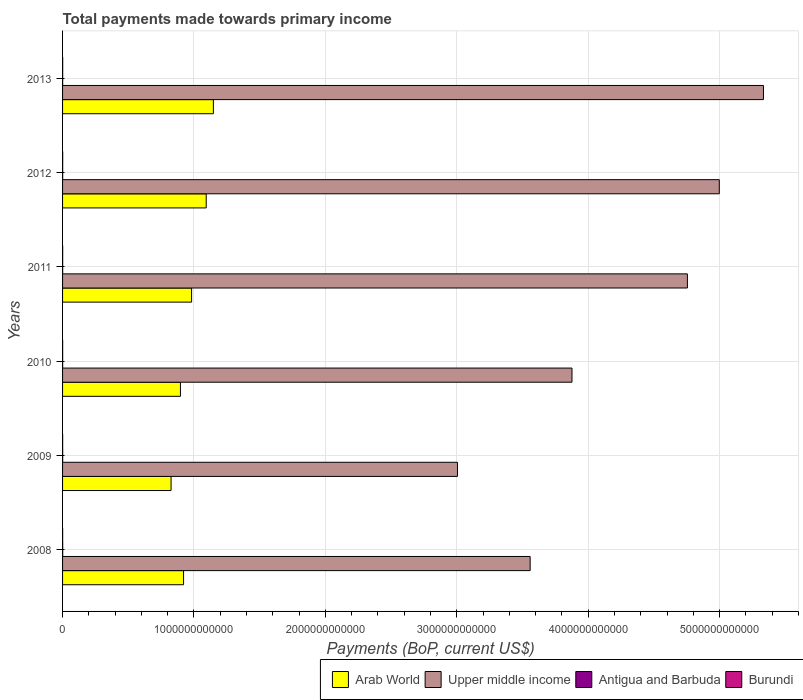Are the number of bars per tick equal to the number of legend labels?
Your answer should be very brief. Yes. Are the number of bars on each tick of the Y-axis equal?
Offer a very short reply. Yes. How many bars are there on the 2nd tick from the top?
Offer a very short reply. 4. What is the label of the 4th group of bars from the top?
Keep it short and to the point. 2010. In how many cases, is the number of bars for a given year not equal to the number of legend labels?
Provide a succinct answer. 0. What is the total payments made towards primary income in Burundi in 2012?
Provide a short and direct response. 9.41e+08. Across all years, what is the maximum total payments made towards primary income in Upper middle income?
Your answer should be compact. 5.33e+12. Across all years, what is the minimum total payments made towards primary income in Burundi?
Provide a succinct answer. 5.38e+08. What is the total total payments made towards primary income in Burundi in the graph?
Your answer should be very brief. 4.42e+09. What is the difference between the total payments made towards primary income in Upper middle income in 2010 and that in 2012?
Keep it short and to the point. -1.12e+12. What is the difference between the total payments made towards primary income in Burundi in 2010 and the total payments made towards primary income in Upper middle income in 2011?
Offer a terse response. -4.75e+12. What is the average total payments made towards primary income in Arab World per year?
Provide a succinct answer. 9.78e+11. In the year 2013, what is the difference between the total payments made towards primary income in Burundi and total payments made towards primary income in Arab World?
Make the answer very short. -1.15e+12. In how many years, is the total payments made towards primary income in Upper middle income greater than 1600000000000 US$?
Keep it short and to the point. 6. What is the ratio of the total payments made towards primary income in Antigua and Barbuda in 2009 to that in 2013?
Your response must be concise. 0.99. What is the difference between the highest and the second highest total payments made towards primary income in Antigua and Barbuda?
Keep it short and to the point. 2.55e+08. What is the difference between the highest and the lowest total payments made towards primary income in Antigua and Barbuda?
Ensure brevity in your answer.  3.38e+08. Is the sum of the total payments made towards primary income in Burundi in 2010 and 2013 greater than the maximum total payments made towards primary income in Arab World across all years?
Make the answer very short. No. Is it the case that in every year, the sum of the total payments made towards primary income in Upper middle income and total payments made towards primary income in Arab World is greater than the sum of total payments made towards primary income in Burundi and total payments made towards primary income in Antigua and Barbuda?
Keep it short and to the point. Yes. What does the 2nd bar from the top in 2008 represents?
Keep it short and to the point. Antigua and Barbuda. What does the 3rd bar from the bottom in 2010 represents?
Offer a very short reply. Antigua and Barbuda. Is it the case that in every year, the sum of the total payments made towards primary income in Upper middle income and total payments made towards primary income in Antigua and Barbuda is greater than the total payments made towards primary income in Arab World?
Provide a short and direct response. Yes. Are all the bars in the graph horizontal?
Give a very brief answer. Yes. How many years are there in the graph?
Offer a very short reply. 6. What is the difference between two consecutive major ticks on the X-axis?
Your answer should be very brief. 1.00e+12. Are the values on the major ticks of X-axis written in scientific E-notation?
Offer a terse response. No. Does the graph contain any zero values?
Keep it short and to the point. No. Does the graph contain grids?
Keep it short and to the point. Yes. Where does the legend appear in the graph?
Keep it short and to the point. Bottom right. What is the title of the graph?
Offer a very short reply. Total payments made towards primary income. Does "Ghana" appear as one of the legend labels in the graph?
Offer a terse response. No. What is the label or title of the X-axis?
Offer a terse response. Payments (BoP, current US$). What is the Payments (BoP, current US$) of Arab World in 2008?
Your answer should be very brief. 9.21e+11. What is the Payments (BoP, current US$) in Upper middle income in 2008?
Provide a short and direct response. 3.56e+12. What is the Payments (BoP, current US$) in Antigua and Barbuda in 2008?
Your response must be concise. 1.03e+09. What is the Payments (BoP, current US$) in Burundi in 2008?
Provide a short and direct response. 6.09e+08. What is the Payments (BoP, current US$) in Arab World in 2009?
Offer a very short reply. 8.26e+11. What is the Payments (BoP, current US$) of Upper middle income in 2009?
Provide a short and direct response. 3.01e+12. What is the Payments (BoP, current US$) of Antigua and Barbuda in 2009?
Your answer should be very brief. 7.70e+08. What is the Payments (BoP, current US$) of Burundi in 2009?
Your response must be concise. 5.38e+08. What is the Payments (BoP, current US$) of Arab World in 2010?
Offer a very short reply. 8.97e+11. What is the Payments (BoP, current US$) in Upper middle income in 2010?
Keep it short and to the point. 3.88e+12. What is the Payments (BoP, current US$) of Antigua and Barbuda in 2010?
Ensure brevity in your answer.  7.22e+08. What is the Payments (BoP, current US$) in Burundi in 2010?
Keep it short and to the point. 6.19e+08. What is the Payments (BoP, current US$) of Arab World in 2011?
Offer a terse response. 9.82e+11. What is the Payments (BoP, current US$) in Upper middle income in 2011?
Give a very brief answer. 4.76e+12. What is the Payments (BoP, current US$) in Antigua and Barbuda in 2011?
Make the answer very short. 6.91e+08. What is the Payments (BoP, current US$) in Burundi in 2011?
Your answer should be compact. 7.90e+08. What is the Payments (BoP, current US$) of Arab World in 2012?
Offer a very short reply. 1.09e+12. What is the Payments (BoP, current US$) of Upper middle income in 2012?
Offer a terse response. 5.00e+12. What is the Payments (BoP, current US$) in Antigua and Barbuda in 2012?
Your answer should be very brief. 7.49e+08. What is the Payments (BoP, current US$) in Burundi in 2012?
Provide a succinct answer. 9.41e+08. What is the Payments (BoP, current US$) of Arab World in 2013?
Keep it short and to the point. 1.15e+12. What is the Payments (BoP, current US$) of Upper middle income in 2013?
Make the answer very short. 5.33e+12. What is the Payments (BoP, current US$) in Antigua and Barbuda in 2013?
Your answer should be very brief. 7.75e+08. What is the Payments (BoP, current US$) in Burundi in 2013?
Offer a very short reply. 9.22e+08. Across all years, what is the maximum Payments (BoP, current US$) in Arab World?
Your answer should be compact. 1.15e+12. Across all years, what is the maximum Payments (BoP, current US$) in Upper middle income?
Your answer should be very brief. 5.33e+12. Across all years, what is the maximum Payments (BoP, current US$) of Antigua and Barbuda?
Ensure brevity in your answer.  1.03e+09. Across all years, what is the maximum Payments (BoP, current US$) in Burundi?
Provide a succinct answer. 9.41e+08. Across all years, what is the minimum Payments (BoP, current US$) of Arab World?
Offer a terse response. 8.26e+11. Across all years, what is the minimum Payments (BoP, current US$) of Upper middle income?
Your answer should be very brief. 3.01e+12. Across all years, what is the minimum Payments (BoP, current US$) of Antigua and Barbuda?
Your answer should be very brief. 6.91e+08. Across all years, what is the minimum Payments (BoP, current US$) in Burundi?
Ensure brevity in your answer.  5.38e+08. What is the total Payments (BoP, current US$) in Arab World in the graph?
Your answer should be very brief. 5.87e+12. What is the total Payments (BoP, current US$) of Upper middle income in the graph?
Your answer should be compact. 2.55e+13. What is the total Payments (BoP, current US$) of Antigua and Barbuda in the graph?
Give a very brief answer. 4.74e+09. What is the total Payments (BoP, current US$) of Burundi in the graph?
Your answer should be very brief. 4.42e+09. What is the difference between the Payments (BoP, current US$) of Arab World in 2008 and that in 2009?
Offer a terse response. 9.51e+1. What is the difference between the Payments (BoP, current US$) in Upper middle income in 2008 and that in 2009?
Your response must be concise. 5.53e+11. What is the difference between the Payments (BoP, current US$) in Antigua and Barbuda in 2008 and that in 2009?
Your response must be concise. 2.59e+08. What is the difference between the Payments (BoP, current US$) in Burundi in 2008 and that in 2009?
Offer a terse response. 7.14e+07. What is the difference between the Payments (BoP, current US$) in Arab World in 2008 and that in 2010?
Provide a short and direct response. 2.38e+1. What is the difference between the Payments (BoP, current US$) of Upper middle income in 2008 and that in 2010?
Provide a succinct answer. -3.18e+11. What is the difference between the Payments (BoP, current US$) of Antigua and Barbuda in 2008 and that in 2010?
Your answer should be very brief. 3.08e+08. What is the difference between the Payments (BoP, current US$) in Burundi in 2008 and that in 2010?
Give a very brief answer. -9.31e+06. What is the difference between the Payments (BoP, current US$) in Arab World in 2008 and that in 2011?
Make the answer very short. -6.11e+1. What is the difference between the Payments (BoP, current US$) of Upper middle income in 2008 and that in 2011?
Your answer should be very brief. -1.20e+12. What is the difference between the Payments (BoP, current US$) of Antigua and Barbuda in 2008 and that in 2011?
Keep it short and to the point. 3.38e+08. What is the difference between the Payments (BoP, current US$) of Burundi in 2008 and that in 2011?
Your answer should be very brief. -1.81e+08. What is the difference between the Payments (BoP, current US$) of Arab World in 2008 and that in 2012?
Provide a short and direct response. -1.72e+11. What is the difference between the Payments (BoP, current US$) of Upper middle income in 2008 and that in 2012?
Your answer should be compact. -1.44e+12. What is the difference between the Payments (BoP, current US$) in Antigua and Barbuda in 2008 and that in 2012?
Provide a short and direct response. 2.80e+08. What is the difference between the Payments (BoP, current US$) in Burundi in 2008 and that in 2012?
Your response must be concise. -3.31e+08. What is the difference between the Payments (BoP, current US$) of Arab World in 2008 and that in 2013?
Give a very brief answer. -2.27e+11. What is the difference between the Payments (BoP, current US$) in Upper middle income in 2008 and that in 2013?
Keep it short and to the point. -1.78e+12. What is the difference between the Payments (BoP, current US$) of Antigua and Barbuda in 2008 and that in 2013?
Offer a very short reply. 2.55e+08. What is the difference between the Payments (BoP, current US$) in Burundi in 2008 and that in 2013?
Offer a terse response. -3.12e+08. What is the difference between the Payments (BoP, current US$) in Arab World in 2009 and that in 2010?
Your answer should be compact. -7.13e+1. What is the difference between the Payments (BoP, current US$) in Upper middle income in 2009 and that in 2010?
Offer a very short reply. -8.71e+11. What is the difference between the Payments (BoP, current US$) of Antigua and Barbuda in 2009 and that in 2010?
Provide a succinct answer. 4.88e+07. What is the difference between the Payments (BoP, current US$) in Burundi in 2009 and that in 2010?
Keep it short and to the point. -8.07e+07. What is the difference between the Payments (BoP, current US$) in Arab World in 2009 and that in 2011?
Your answer should be very brief. -1.56e+11. What is the difference between the Payments (BoP, current US$) of Upper middle income in 2009 and that in 2011?
Give a very brief answer. -1.75e+12. What is the difference between the Payments (BoP, current US$) in Antigua and Barbuda in 2009 and that in 2011?
Make the answer very short. 7.91e+07. What is the difference between the Payments (BoP, current US$) in Burundi in 2009 and that in 2011?
Ensure brevity in your answer.  -2.52e+08. What is the difference between the Payments (BoP, current US$) of Arab World in 2009 and that in 2012?
Your answer should be very brief. -2.68e+11. What is the difference between the Payments (BoP, current US$) in Upper middle income in 2009 and that in 2012?
Give a very brief answer. -1.99e+12. What is the difference between the Payments (BoP, current US$) in Antigua and Barbuda in 2009 and that in 2012?
Ensure brevity in your answer.  2.12e+07. What is the difference between the Payments (BoP, current US$) in Burundi in 2009 and that in 2012?
Offer a terse response. -4.03e+08. What is the difference between the Payments (BoP, current US$) of Arab World in 2009 and that in 2013?
Ensure brevity in your answer.  -3.22e+11. What is the difference between the Payments (BoP, current US$) in Upper middle income in 2009 and that in 2013?
Make the answer very short. -2.33e+12. What is the difference between the Payments (BoP, current US$) in Antigua and Barbuda in 2009 and that in 2013?
Provide a short and direct response. -4.27e+06. What is the difference between the Payments (BoP, current US$) in Burundi in 2009 and that in 2013?
Make the answer very short. -3.84e+08. What is the difference between the Payments (BoP, current US$) in Arab World in 2010 and that in 2011?
Offer a terse response. -8.49e+1. What is the difference between the Payments (BoP, current US$) of Upper middle income in 2010 and that in 2011?
Keep it short and to the point. -8.78e+11. What is the difference between the Payments (BoP, current US$) of Antigua and Barbuda in 2010 and that in 2011?
Ensure brevity in your answer.  3.02e+07. What is the difference between the Payments (BoP, current US$) in Burundi in 2010 and that in 2011?
Your answer should be very brief. -1.72e+08. What is the difference between the Payments (BoP, current US$) in Arab World in 2010 and that in 2012?
Provide a succinct answer. -1.96e+11. What is the difference between the Payments (BoP, current US$) in Upper middle income in 2010 and that in 2012?
Your answer should be compact. -1.12e+12. What is the difference between the Payments (BoP, current US$) in Antigua and Barbuda in 2010 and that in 2012?
Your response must be concise. -2.77e+07. What is the difference between the Payments (BoP, current US$) of Burundi in 2010 and that in 2012?
Keep it short and to the point. -3.22e+08. What is the difference between the Payments (BoP, current US$) of Arab World in 2010 and that in 2013?
Your answer should be very brief. -2.51e+11. What is the difference between the Payments (BoP, current US$) of Upper middle income in 2010 and that in 2013?
Offer a terse response. -1.46e+12. What is the difference between the Payments (BoP, current US$) in Antigua and Barbuda in 2010 and that in 2013?
Ensure brevity in your answer.  -5.31e+07. What is the difference between the Payments (BoP, current US$) in Burundi in 2010 and that in 2013?
Give a very brief answer. -3.03e+08. What is the difference between the Payments (BoP, current US$) in Arab World in 2011 and that in 2012?
Ensure brevity in your answer.  -1.11e+11. What is the difference between the Payments (BoP, current US$) in Upper middle income in 2011 and that in 2012?
Offer a very short reply. -2.43e+11. What is the difference between the Payments (BoP, current US$) of Antigua and Barbuda in 2011 and that in 2012?
Provide a succinct answer. -5.79e+07. What is the difference between the Payments (BoP, current US$) of Burundi in 2011 and that in 2012?
Ensure brevity in your answer.  -1.50e+08. What is the difference between the Payments (BoP, current US$) in Arab World in 2011 and that in 2013?
Give a very brief answer. -1.66e+11. What is the difference between the Payments (BoP, current US$) in Upper middle income in 2011 and that in 2013?
Offer a very short reply. -5.79e+11. What is the difference between the Payments (BoP, current US$) of Antigua and Barbuda in 2011 and that in 2013?
Your answer should be compact. -8.33e+07. What is the difference between the Payments (BoP, current US$) in Burundi in 2011 and that in 2013?
Give a very brief answer. -1.32e+08. What is the difference between the Payments (BoP, current US$) in Arab World in 2012 and that in 2013?
Your answer should be very brief. -5.44e+1. What is the difference between the Payments (BoP, current US$) in Upper middle income in 2012 and that in 2013?
Provide a short and direct response. -3.36e+11. What is the difference between the Payments (BoP, current US$) in Antigua and Barbuda in 2012 and that in 2013?
Keep it short and to the point. -2.54e+07. What is the difference between the Payments (BoP, current US$) of Burundi in 2012 and that in 2013?
Ensure brevity in your answer.  1.87e+07. What is the difference between the Payments (BoP, current US$) in Arab World in 2008 and the Payments (BoP, current US$) in Upper middle income in 2009?
Your response must be concise. -2.08e+12. What is the difference between the Payments (BoP, current US$) in Arab World in 2008 and the Payments (BoP, current US$) in Antigua and Barbuda in 2009?
Ensure brevity in your answer.  9.20e+11. What is the difference between the Payments (BoP, current US$) of Arab World in 2008 and the Payments (BoP, current US$) of Burundi in 2009?
Give a very brief answer. 9.20e+11. What is the difference between the Payments (BoP, current US$) in Upper middle income in 2008 and the Payments (BoP, current US$) in Antigua and Barbuda in 2009?
Your answer should be very brief. 3.56e+12. What is the difference between the Payments (BoP, current US$) of Upper middle income in 2008 and the Payments (BoP, current US$) of Burundi in 2009?
Keep it short and to the point. 3.56e+12. What is the difference between the Payments (BoP, current US$) in Antigua and Barbuda in 2008 and the Payments (BoP, current US$) in Burundi in 2009?
Your answer should be compact. 4.91e+08. What is the difference between the Payments (BoP, current US$) of Arab World in 2008 and the Payments (BoP, current US$) of Upper middle income in 2010?
Provide a succinct answer. -2.96e+12. What is the difference between the Payments (BoP, current US$) in Arab World in 2008 and the Payments (BoP, current US$) in Antigua and Barbuda in 2010?
Make the answer very short. 9.20e+11. What is the difference between the Payments (BoP, current US$) in Arab World in 2008 and the Payments (BoP, current US$) in Burundi in 2010?
Your answer should be compact. 9.20e+11. What is the difference between the Payments (BoP, current US$) of Upper middle income in 2008 and the Payments (BoP, current US$) of Antigua and Barbuda in 2010?
Provide a succinct answer. 3.56e+12. What is the difference between the Payments (BoP, current US$) of Upper middle income in 2008 and the Payments (BoP, current US$) of Burundi in 2010?
Ensure brevity in your answer.  3.56e+12. What is the difference between the Payments (BoP, current US$) of Antigua and Barbuda in 2008 and the Payments (BoP, current US$) of Burundi in 2010?
Give a very brief answer. 4.11e+08. What is the difference between the Payments (BoP, current US$) of Arab World in 2008 and the Payments (BoP, current US$) of Upper middle income in 2011?
Provide a short and direct response. -3.83e+12. What is the difference between the Payments (BoP, current US$) of Arab World in 2008 and the Payments (BoP, current US$) of Antigua and Barbuda in 2011?
Provide a short and direct response. 9.20e+11. What is the difference between the Payments (BoP, current US$) in Arab World in 2008 and the Payments (BoP, current US$) in Burundi in 2011?
Keep it short and to the point. 9.20e+11. What is the difference between the Payments (BoP, current US$) of Upper middle income in 2008 and the Payments (BoP, current US$) of Antigua and Barbuda in 2011?
Offer a terse response. 3.56e+12. What is the difference between the Payments (BoP, current US$) of Upper middle income in 2008 and the Payments (BoP, current US$) of Burundi in 2011?
Your answer should be compact. 3.56e+12. What is the difference between the Payments (BoP, current US$) of Antigua and Barbuda in 2008 and the Payments (BoP, current US$) of Burundi in 2011?
Provide a succinct answer. 2.39e+08. What is the difference between the Payments (BoP, current US$) in Arab World in 2008 and the Payments (BoP, current US$) in Upper middle income in 2012?
Offer a very short reply. -4.08e+12. What is the difference between the Payments (BoP, current US$) in Arab World in 2008 and the Payments (BoP, current US$) in Antigua and Barbuda in 2012?
Keep it short and to the point. 9.20e+11. What is the difference between the Payments (BoP, current US$) of Arab World in 2008 and the Payments (BoP, current US$) of Burundi in 2012?
Your answer should be compact. 9.20e+11. What is the difference between the Payments (BoP, current US$) of Upper middle income in 2008 and the Payments (BoP, current US$) of Antigua and Barbuda in 2012?
Give a very brief answer. 3.56e+12. What is the difference between the Payments (BoP, current US$) of Upper middle income in 2008 and the Payments (BoP, current US$) of Burundi in 2012?
Offer a very short reply. 3.56e+12. What is the difference between the Payments (BoP, current US$) in Antigua and Barbuda in 2008 and the Payments (BoP, current US$) in Burundi in 2012?
Make the answer very short. 8.88e+07. What is the difference between the Payments (BoP, current US$) in Arab World in 2008 and the Payments (BoP, current US$) in Upper middle income in 2013?
Keep it short and to the point. -4.41e+12. What is the difference between the Payments (BoP, current US$) of Arab World in 2008 and the Payments (BoP, current US$) of Antigua and Barbuda in 2013?
Your answer should be compact. 9.20e+11. What is the difference between the Payments (BoP, current US$) in Arab World in 2008 and the Payments (BoP, current US$) in Burundi in 2013?
Your answer should be compact. 9.20e+11. What is the difference between the Payments (BoP, current US$) in Upper middle income in 2008 and the Payments (BoP, current US$) in Antigua and Barbuda in 2013?
Offer a terse response. 3.56e+12. What is the difference between the Payments (BoP, current US$) in Upper middle income in 2008 and the Payments (BoP, current US$) in Burundi in 2013?
Provide a succinct answer. 3.56e+12. What is the difference between the Payments (BoP, current US$) in Antigua and Barbuda in 2008 and the Payments (BoP, current US$) in Burundi in 2013?
Offer a very short reply. 1.07e+08. What is the difference between the Payments (BoP, current US$) in Arab World in 2009 and the Payments (BoP, current US$) in Upper middle income in 2010?
Give a very brief answer. -3.05e+12. What is the difference between the Payments (BoP, current US$) of Arab World in 2009 and the Payments (BoP, current US$) of Antigua and Barbuda in 2010?
Keep it short and to the point. 8.25e+11. What is the difference between the Payments (BoP, current US$) in Arab World in 2009 and the Payments (BoP, current US$) in Burundi in 2010?
Keep it short and to the point. 8.25e+11. What is the difference between the Payments (BoP, current US$) in Upper middle income in 2009 and the Payments (BoP, current US$) in Antigua and Barbuda in 2010?
Your answer should be compact. 3.00e+12. What is the difference between the Payments (BoP, current US$) in Upper middle income in 2009 and the Payments (BoP, current US$) in Burundi in 2010?
Offer a very short reply. 3.00e+12. What is the difference between the Payments (BoP, current US$) of Antigua and Barbuda in 2009 and the Payments (BoP, current US$) of Burundi in 2010?
Offer a very short reply. 1.52e+08. What is the difference between the Payments (BoP, current US$) of Arab World in 2009 and the Payments (BoP, current US$) of Upper middle income in 2011?
Your answer should be compact. -3.93e+12. What is the difference between the Payments (BoP, current US$) in Arab World in 2009 and the Payments (BoP, current US$) in Antigua and Barbuda in 2011?
Offer a terse response. 8.25e+11. What is the difference between the Payments (BoP, current US$) of Arab World in 2009 and the Payments (BoP, current US$) of Burundi in 2011?
Provide a short and direct response. 8.25e+11. What is the difference between the Payments (BoP, current US$) of Upper middle income in 2009 and the Payments (BoP, current US$) of Antigua and Barbuda in 2011?
Your answer should be compact. 3.00e+12. What is the difference between the Payments (BoP, current US$) in Upper middle income in 2009 and the Payments (BoP, current US$) in Burundi in 2011?
Offer a very short reply. 3.00e+12. What is the difference between the Payments (BoP, current US$) of Antigua and Barbuda in 2009 and the Payments (BoP, current US$) of Burundi in 2011?
Your answer should be compact. -1.99e+07. What is the difference between the Payments (BoP, current US$) in Arab World in 2009 and the Payments (BoP, current US$) in Upper middle income in 2012?
Your response must be concise. -4.17e+12. What is the difference between the Payments (BoP, current US$) in Arab World in 2009 and the Payments (BoP, current US$) in Antigua and Barbuda in 2012?
Make the answer very short. 8.25e+11. What is the difference between the Payments (BoP, current US$) in Arab World in 2009 and the Payments (BoP, current US$) in Burundi in 2012?
Keep it short and to the point. 8.25e+11. What is the difference between the Payments (BoP, current US$) in Upper middle income in 2009 and the Payments (BoP, current US$) in Antigua and Barbuda in 2012?
Provide a succinct answer. 3.00e+12. What is the difference between the Payments (BoP, current US$) of Upper middle income in 2009 and the Payments (BoP, current US$) of Burundi in 2012?
Your answer should be very brief. 3.00e+12. What is the difference between the Payments (BoP, current US$) of Antigua and Barbuda in 2009 and the Payments (BoP, current US$) of Burundi in 2012?
Ensure brevity in your answer.  -1.70e+08. What is the difference between the Payments (BoP, current US$) of Arab World in 2009 and the Payments (BoP, current US$) of Upper middle income in 2013?
Provide a succinct answer. -4.51e+12. What is the difference between the Payments (BoP, current US$) of Arab World in 2009 and the Payments (BoP, current US$) of Antigua and Barbuda in 2013?
Your answer should be very brief. 8.25e+11. What is the difference between the Payments (BoP, current US$) of Arab World in 2009 and the Payments (BoP, current US$) of Burundi in 2013?
Offer a very short reply. 8.25e+11. What is the difference between the Payments (BoP, current US$) of Upper middle income in 2009 and the Payments (BoP, current US$) of Antigua and Barbuda in 2013?
Your response must be concise. 3.00e+12. What is the difference between the Payments (BoP, current US$) in Upper middle income in 2009 and the Payments (BoP, current US$) in Burundi in 2013?
Make the answer very short. 3.00e+12. What is the difference between the Payments (BoP, current US$) in Antigua and Barbuda in 2009 and the Payments (BoP, current US$) in Burundi in 2013?
Make the answer very short. -1.52e+08. What is the difference between the Payments (BoP, current US$) of Arab World in 2010 and the Payments (BoP, current US$) of Upper middle income in 2011?
Offer a terse response. -3.86e+12. What is the difference between the Payments (BoP, current US$) of Arab World in 2010 and the Payments (BoP, current US$) of Antigua and Barbuda in 2011?
Your answer should be very brief. 8.96e+11. What is the difference between the Payments (BoP, current US$) of Arab World in 2010 and the Payments (BoP, current US$) of Burundi in 2011?
Your response must be concise. 8.96e+11. What is the difference between the Payments (BoP, current US$) of Upper middle income in 2010 and the Payments (BoP, current US$) of Antigua and Barbuda in 2011?
Ensure brevity in your answer.  3.88e+12. What is the difference between the Payments (BoP, current US$) of Upper middle income in 2010 and the Payments (BoP, current US$) of Burundi in 2011?
Your answer should be very brief. 3.88e+12. What is the difference between the Payments (BoP, current US$) of Antigua and Barbuda in 2010 and the Payments (BoP, current US$) of Burundi in 2011?
Offer a terse response. -6.87e+07. What is the difference between the Payments (BoP, current US$) of Arab World in 2010 and the Payments (BoP, current US$) of Upper middle income in 2012?
Offer a terse response. -4.10e+12. What is the difference between the Payments (BoP, current US$) in Arab World in 2010 and the Payments (BoP, current US$) in Antigua and Barbuda in 2012?
Ensure brevity in your answer.  8.96e+11. What is the difference between the Payments (BoP, current US$) of Arab World in 2010 and the Payments (BoP, current US$) of Burundi in 2012?
Provide a succinct answer. 8.96e+11. What is the difference between the Payments (BoP, current US$) of Upper middle income in 2010 and the Payments (BoP, current US$) of Antigua and Barbuda in 2012?
Provide a succinct answer. 3.88e+12. What is the difference between the Payments (BoP, current US$) of Upper middle income in 2010 and the Payments (BoP, current US$) of Burundi in 2012?
Offer a very short reply. 3.88e+12. What is the difference between the Payments (BoP, current US$) in Antigua and Barbuda in 2010 and the Payments (BoP, current US$) in Burundi in 2012?
Offer a terse response. -2.19e+08. What is the difference between the Payments (BoP, current US$) of Arab World in 2010 and the Payments (BoP, current US$) of Upper middle income in 2013?
Provide a succinct answer. -4.44e+12. What is the difference between the Payments (BoP, current US$) of Arab World in 2010 and the Payments (BoP, current US$) of Antigua and Barbuda in 2013?
Provide a short and direct response. 8.96e+11. What is the difference between the Payments (BoP, current US$) in Arab World in 2010 and the Payments (BoP, current US$) in Burundi in 2013?
Provide a succinct answer. 8.96e+11. What is the difference between the Payments (BoP, current US$) in Upper middle income in 2010 and the Payments (BoP, current US$) in Antigua and Barbuda in 2013?
Your response must be concise. 3.88e+12. What is the difference between the Payments (BoP, current US$) of Upper middle income in 2010 and the Payments (BoP, current US$) of Burundi in 2013?
Keep it short and to the point. 3.88e+12. What is the difference between the Payments (BoP, current US$) of Antigua and Barbuda in 2010 and the Payments (BoP, current US$) of Burundi in 2013?
Offer a very short reply. -2.00e+08. What is the difference between the Payments (BoP, current US$) of Arab World in 2011 and the Payments (BoP, current US$) of Upper middle income in 2012?
Your answer should be compact. -4.02e+12. What is the difference between the Payments (BoP, current US$) in Arab World in 2011 and the Payments (BoP, current US$) in Antigua and Barbuda in 2012?
Offer a terse response. 9.81e+11. What is the difference between the Payments (BoP, current US$) in Arab World in 2011 and the Payments (BoP, current US$) in Burundi in 2012?
Your answer should be compact. 9.81e+11. What is the difference between the Payments (BoP, current US$) in Upper middle income in 2011 and the Payments (BoP, current US$) in Antigua and Barbuda in 2012?
Provide a short and direct response. 4.75e+12. What is the difference between the Payments (BoP, current US$) in Upper middle income in 2011 and the Payments (BoP, current US$) in Burundi in 2012?
Ensure brevity in your answer.  4.75e+12. What is the difference between the Payments (BoP, current US$) in Antigua and Barbuda in 2011 and the Payments (BoP, current US$) in Burundi in 2012?
Provide a short and direct response. -2.49e+08. What is the difference between the Payments (BoP, current US$) in Arab World in 2011 and the Payments (BoP, current US$) in Upper middle income in 2013?
Give a very brief answer. -4.35e+12. What is the difference between the Payments (BoP, current US$) of Arab World in 2011 and the Payments (BoP, current US$) of Antigua and Barbuda in 2013?
Your answer should be very brief. 9.81e+11. What is the difference between the Payments (BoP, current US$) of Arab World in 2011 and the Payments (BoP, current US$) of Burundi in 2013?
Your response must be concise. 9.81e+11. What is the difference between the Payments (BoP, current US$) of Upper middle income in 2011 and the Payments (BoP, current US$) of Antigua and Barbuda in 2013?
Give a very brief answer. 4.75e+12. What is the difference between the Payments (BoP, current US$) of Upper middle income in 2011 and the Payments (BoP, current US$) of Burundi in 2013?
Keep it short and to the point. 4.75e+12. What is the difference between the Payments (BoP, current US$) of Antigua and Barbuda in 2011 and the Payments (BoP, current US$) of Burundi in 2013?
Keep it short and to the point. -2.31e+08. What is the difference between the Payments (BoP, current US$) of Arab World in 2012 and the Payments (BoP, current US$) of Upper middle income in 2013?
Your response must be concise. -4.24e+12. What is the difference between the Payments (BoP, current US$) of Arab World in 2012 and the Payments (BoP, current US$) of Antigua and Barbuda in 2013?
Your answer should be very brief. 1.09e+12. What is the difference between the Payments (BoP, current US$) in Arab World in 2012 and the Payments (BoP, current US$) in Burundi in 2013?
Your response must be concise. 1.09e+12. What is the difference between the Payments (BoP, current US$) in Upper middle income in 2012 and the Payments (BoP, current US$) in Antigua and Barbuda in 2013?
Your answer should be compact. 5.00e+12. What is the difference between the Payments (BoP, current US$) of Upper middle income in 2012 and the Payments (BoP, current US$) of Burundi in 2013?
Offer a very short reply. 5.00e+12. What is the difference between the Payments (BoP, current US$) in Antigua and Barbuda in 2012 and the Payments (BoP, current US$) in Burundi in 2013?
Your answer should be very brief. -1.73e+08. What is the average Payments (BoP, current US$) of Arab World per year?
Provide a succinct answer. 9.78e+11. What is the average Payments (BoP, current US$) in Upper middle income per year?
Your answer should be very brief. 4.25e+12. What is the average Payments (BoP, current US$) of Antigua and Barbuda per year?
Your response must be concise. 7.89e+08. What is the average Payments (BoP, current US$) in Burundi per year?
Offer a terse response. 7.36e+08. In the year 2008, what is the difference between the Payments (BoP, current US$) in Arab World and Payments (BoP, current US$) in Upper middle income?
Offer a terse response. -2.64e+12. In the year 2008, what is the difference between the Payments (BoP, current US$) of Arab World and Payments (BoP, current US$) of Antigua and Barbuda?
Your response must be concise. 9.20e+11. In the year 2008, what is the difference between the Payments (BoP, current US$) of Arab World and Payments (BoP, current US$) of Burundi?
Keep it short and to the point. 9.20e+11. In the year 2008, what is the difference between the Payments (BoP, current US$) of Upper middle income and Payments (BoP, current US$) of Antigua and Barbuda?
Keep it short and to the point. 3.56e+12. In the year 2008, what is the difference between the Payments (BoP, current US$) in Upper middle income and Payments (BoP, current US$) in Burundi?
Provide a short and direct response. 3.56e+12. In the year 2008, what is the difference between the Payments (BoP, current US$) of Antigua and Barbuda and Payments (BoP, current US$) of Burundi?
Offer a very short reply. 4.20e+08. In the year 2009, what is the difference between the Payments (BoP, current US$) of Arab World and Payments (BoP, current US$) of Upper middle income?
Your answer should be very brief. -2.18e+12. In the year 2009, what is the difference between the Payments (BoP, current US$) in Arab World and Payments (BoP, current US$) in Antigua and Barbuda?
Provide a succinct answer. 8.25e+11. In the year 2009, what is the difference between the Payments (BoP, current US$) in Arab World and Payments (BoP, current US$) in Burundi?
Your answer should be compact. 8.25e+11. In the year 2009, what is the difference between the Payments (BoP, current US$) of Upper middle income and Payments (BoP, current US$) of Antigua and Barbuda?
Provide a succinct answer. 3.00e+12. In the year 2009, what is the difference between the Payments (BoP, current US$) of Upper middle income and Payments (BoP, current US$) of Burundi?
Provide a short and direct response. 3.00e+12. In the year 2009, what is the difference between the Payments (BoP, current US$) of Antigua and Barbuda and Payments (BoP, current US$) of Burundi?
Your answer should be compact. 2.32e+08. In the year 2010, what is the difference between the Payments (BoP, current US$) in Arab World and Payments (BoP, current US$) in Upper middle income?
Keep it short and to the point. -2.98e+12. In the year 2010, what is the difference between the Payments (BoP, current US$) of Arab World and Payments (BoP, current US$) of Antigua and Barbuda?
Keep it short and to the point. 8.96e+11. In the year 2010, what is the difference between the Payments (BoP, current US$) of Arab World and Payments (BoP, current US$) of Burundi?
Offer a very short reply. 8.96e+11. In the year 2010, what is the difference between the Payments (BoP, current US$) in Upper middle income and Payments (BoP, current US$) in Antigua and Barbuda?
Offer a very short reply. 3.88e+12. In the year 2010, what is the difference between the Payments (BoP, current US$) of Upper middle income and Payments (BoP, current US$) of Burundi?
Your response must be concise. 3.88e+12. In the year 2010, what is the difference between the Payments (BoP, current US$) of Antigua and Barbuda and Payments (BoP, current US$) of Burundi?
Your answer should be very brief. 1.03e+08. In the year 2011, what is the difference between the Payments (BoP, current US$) in Arab World and Payments (BoP, current US$) in Upper middle income?
Your answer should be compact. -3.77e+12. In the year 2011, what is the difference between the Payments (BoP, current US$) in Arab World and Payments (BoP, current US$) in Antigua and Barbuda?
Keep it short and to the point. 9.81e+11. In the year 2011, what is the difference between the Payments (BoP, current US$) in Arab World and Payments (BoP, current US$) in Burundi?
Give a very brief answer. 9.81e+11. In the year 2011, what is the difference between the Payments (BoP, current US$) of Upper middle income and Payments (BoP, current US$) of Antigua and Barbuda?
Offer a terse response. 4.75e+12. In the year 2011, what is the difference between the Payments (BoP, current US$) in Upper middle income and Payments (BoP, current US$) in Burundi?
Make the answer very short. 4.75e+12. In the year 2011, what is the difference between the Payments (BoP, current US$) in Antigua and Barbuda and Payments (BoP, current US$) in Burundi?
Offer a very short reply. -9.89e+07. In the year 2012, what is the difference between the Payments (BoP, current US$) of Arab World and Payments (BoP, current US$) of Upper middle income?
Provide a short and direct response. -3.90e+12. In the year 2012, what is the difference between the Payments (BoP, current US$) in Arab World and Payments (BoP, current US$) in Antigua and Barbuda?
Offer a very short reply. 1.09e+12. In the year 2012, what is the difference between the Payments (BoP, current US$) in Arab World and Payments (BoP, current US$) in Burundi?
Provide a short and direct response. 1.09e+12. In the year 2012, what is the difference between the Payments (BoP, current US$) of Upper middle income and Payments (BoP, current US$) of Antigua and Barbuda?
Make the answer very short. 5.00e+12. In the year 2012, what is the difference between the Payments (BoP, current US$) of Upper middle income and Payments (BoP, current US$) of Burundi?
Offer a terse response. 5.00e+12. In the year 2012, what is the difference between the Payments (BoP, current US$) in Antigua and Barbuda and Payments (BoP, current US$) in Burundi?
Your answer should be very brief. -1.91e+08. In the year 2013, what is the difference between the Payments (BoP, current US$) in Arab World and Payments (BoP, current US$) in Upper middle income?
Offer a terse response. -4.19e+12. In the year 2013, what is the difference between the Payments (BoP, current US$) in Arab World and Payments (BoP, current US$) in Antigua and Barbuda?
Make the answer very short. 1.15e+12. In the year 2013, what is the difference between the Payments (BoP, current US$) of Arab World and Payments (BoP, current US$) of Burundi?
Provide a short and direct response. 1.15e+12. In the year 2013, what is the difference between the Payments (BoP, current US$) in Upper middle income and Payments (BoP, current US$) in Antigua and Barbuda?
Provide a succinct answer. 5.33e+12. In the year 2013, what is the difference between the Payments (BoP, current US$) of Upper middle income and Payments (BoP, current US$) of Burundi?
Give a very brief answer. 5.33e+12. In the year 2013, what is the difference between the Payments (BoP, current US$) of Antigua and Barbuda and Payments (BoP, current US$) of Burundi?
Offer a very short reply. -1.47e+08. What is the ratio of the Payments (BoP, current US$) in Arab World in 2008 to that in 2009?
Your response must be concise. 1.12. What is the ratio of the Payments (BoP, current US$) of Upper middle income in 2008 to that in 2009?
Keep it short and to the point. 1.18. What is the ratio of the Payments (BoP, current US$) of Antigua and Barbuda in 2008 to that in 2009?
Keep it short and to the point. 1.34. What is the ratio of the Payments (BoP, current US$) of Burundi in 2008 to that in 2009?
Your response must be concise. 1.13. What is the ratio of the Payments (BoP, current US$) in Arab World in 2008 to that in 2010?
Offer a very short reply. 1.03. What is the ratio of the Payments (BoP, current US$) in Upper middle income in 2008 to that in 2010?
Give a very brief answer. 0.92. What is the ratio of the Payments (BoP, current US$) in Antigua and Barbuda in 2008 to that in 2010?
Provide a short and direct response. 1.43. What is the ratio of the Payments (BoP, current US$) of Burundi in 2008 to that in 2010?
Make the answer very short. 0.98. What is the ratio of the Payments (BoP, current US$) of Arab World in 2008 to that in 2011?
Provide a short and direct response. 0.94. What is the ratio of the Payments (BoP, current US$) in Upper middle income in 2008 to that in 2011?
Your response must be concise. 0.75. What is the ratio of the Payments (BoP, current US$) of Antigua and Barbuda in 2008 to that in 2011?
Your response must be concise. 1.49. What is the ratio of the Payments (BoP, current US$) in Burundi in 2008 to that in 2011?
Keep it short and to the point. 0.77. What is the ratio of the Payments (BoP, current US$) in Arab World in 2008 to that in 2012?
Provide a succinct answer. 0.84. What is the ratio of the Payments (BoP, current US$) in Upper middle income in 2008 to that in 2012?
Your answer should be very brief. 0.71. What is the ratio of the Payments (BoP, current US$) in Antigua and Barbuda in 2008 to that in 2012?
Your answer should be very brief. 1.37. What is the ratio of the Payments (BoP, current US$) in Burundi in 2008 to that in 2012?
Your answer should be compact. 0.65. What is the ratio of the Payments (BoP, current US$) in Arab World in 2008 to that in 2013?
Offer a very short reply. 0.8. What is the ratio of the Payments (BoP, current US$) in Upper middle income in 2008 to that in 2013?
Provide a short and direct response. 0.67. What is the ratio of the Payments (BoP, current US$) of Antigua and Barbuda in 2008 to that in 2013?
Offer a terse response. 1.33. What is the ratio of the Payments (BoP, current US$) of Burundi in 2008 to that in 2013?
Make the answer very short. 0.66. What is the ratio of the Payments (BoP, current US$) in Arab World in 2009 to that in 2010?
Ensure brevity in your answer.  0.92. What is the ratio of the Payments (BoP, current US$) in Upper middle income in 2009 to that in 2010?
Offer a terse response. 0.78. What is the ratio of the Payments (BoP, current US$) of Antigua and Barbuda in 2009 to that in 2010?
Your answer should be compact. 1.07. What is the ratio of the Payments (BoP, current US$) of Burundi in 2009 to that in 2010?
Your answer should be very brief. 0.87. What is the ratio of the Payments (BoP, current US$) of Arab World in 2009 to that in 2011?
Make the answer very short. 0.84. What is the ratio of the Payments (BoP, current US$) of Upper middle income in 2009 to that in 2011?
Your answer should be compact. 0.63. What is the ratio of the Payments (BoP, current US$) in Antigua and Barbuda in 2009 to that in 2011?
Your answer should be very brief. 1.11. What is the ratio of the Payments (BoP, current US$) in Burundi in 2009 to that in 2011?
Your response must be concise. 0.68. What is the ratio of the Payments (BoP, current US$) of Arab World in 2009 to that in 2012?
Make the answer very short. 0.76. What is the ratio of the Payments (BoP, current US$) of Upper middle income in 2009 to that in 2012?
Offer a terse response. 0.6. What is the ratio of the Payments (BoP, current US$) in Antigua and Barbuda in 2009 to that in 2012?
Keep it short and to the point. 1.03. What is the ratio of the Payments (BoP, current US$) of Burundi in 2009 to that in 2012?
Keep it short and to the point. 0.57. What is the ratio of the Payments (BoP, current US$) of Arab World in 2009 to that in 2013?
Offer a terse response. 0.72. What is the ratio of the Payments (BoP, current US$) of Upper middle income in 2009 to that in 2013?
Offer a very short reply. 0.56. What is the ratio of the Payments (BoP, current US$) of Burundi in 2009 to that in 2013?
Provide a succinct answer. 0.58. What is the ratio of the Payments (BoP, current US$) in Arab World in 2010 to that in 2011?
Offer a very short reply. 0.91. What is the ratio of the Payments (BoP, current US$) of Upper middle income in 2010 to that in 2011?
Ensure brevity in your answer.  0.82. What is the ratio of the Payments (BoP, current US$) in Antigua and Barbuda in 2010 to that in 2011?
Give a very brief answer. 1.04. What is the ratio of the Payments (BoP, current US$) in Burundi in 2010 to that in 2011?
Make the answer very short. 0.78. What is the ratio of the Payments (BoP, current US$) of Arab World in 2010 to that in 2012?
Offer a terse response. 0.82. What is the ratio of the Payments (BoP, current US$) of Upper middle income in 2010 to that in 2012?
Ensure brevity in your answer.  0.78. What is the ratio of the Payments (BoP, current US$) of Antigua and Barbuda in 2010 to that in 2012?
Your answer should be very brief. 0.96. What is the ratio of the Payments (BoP, current US$) of Burundi in 2010 to that in 2012?
Your answer should be compact. 0.66. What is the ratio of the Payments (BoP, current US$) of Arab World in 2010 to that in 2013?
Your response must be concise. 0.78. What is the ratio of the Payments (BoP, current US$) in Upper middle income in 2010 to that in 2013?
Offer a terse response. 0.73. What is the ratio of the Payments (BoP, current US$) in Antigua and Barbuda in 2010 to that in 2013?
Your answer should be compact. 0.93. What is the ratio of the Payments (BoP, current US$) of Burundi in 2010 to that in 2013?
Provide a succinct answer. 0.67. What is the ratio of the Payments (BoP, current US$) in Arab World in 2011 to that in 2012?
Offer a terse response. 0.9. What is the ratio of the Payments (BoP, current US$) in Upper middle income in 2011 to that in 2012?
Offer a very short reply. 0.95. What is the ratio of the Payments (BoP, current US$) of Antigua and Barbuda in 2011 to that in 2012?
Your response must be concise. 0.92. What is the ratio of the Payments (BoP, current US$) of Burundi in 2011 to that in 2012?
Your response must be concise. 0.84. What is the ratio of the Payments (BoP, current US$) of Arab World in 2011 to that in 2013?
Keep it short and to the point. 0.86. What is the ratio of the Payments (BoP, current US$) of Upper middle income in 2011 to that in 2013?
Provide a succinct answer. 0.89. What is the ratio of the Payments (BoP, current US$) of Antigua and Barbuda in 2011 to that in 2013?
Keep it short and to the point. 0.89. What is the ratio of the Payments (BoP, current US$) in Burundi in 2011 to that in 2013?
Offer a very short reply. 0.86. What is the ratio of the Payments (BoP, current US$) of Arab World in 2012 to that in 2013?
Ensure brevity in your answer.  0.95. What is the ratio of the Payments (BoP, current US$) in Upper middle income in 2012 to that in 2013?
Provide a succinct answer. 0.94. What is the ratio of the Payments (BoP, current US$) of Antigua and Barbuda in 2012 to that in 2013?
Ensure brevity in your answer.  0.97. What is the ratio of the Payments (BoP, current US$) of Burundi in 2012 to that in 2013?
Make the answer very short. 1.02. What is the difference between the highest and the second highest Payments (BoP, current US$) in Arab World?
Ensure brevity in your answer.  5.44e+1. What is the difference between the highest and the second highest Payments (BoP, current US$) in Upper middle income?
Offer a terse response. 3.36e+11. What is the difference between the highest and the second highest Payments (BoP, current US$) of Antigua and Barbuda?
Keep it short and to the point. 2.55e+08. What is the difference between the highest and the second highest Payments (BoP, current US$) in Burundi?
Provide a short and direct response. 1.87e+07. What is the difference between the highest and the lowest Payments (BoP, current US$) of Arab World?
Your answer should be compact. 3.22e+11. What is the difference between the highest and the lowest Payments (BoP, current US$) in Upper middle income?
Offer a terse response. 2.33e+12. What is the difference between the highest and the lowest Payments (BoP, current US$) in Antigua and Barbuda?
Keep it short and to the point. 3.38e+08. What is the difference between the highest and the lowest Payments (BoP, current US$) of Burundi?
Give a very brief answer. 4.03e+08. 